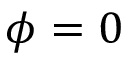Convert formula to latex. <formula><loc_0><loc_0><loc_500><loc_500>\phi = 0</formula> 